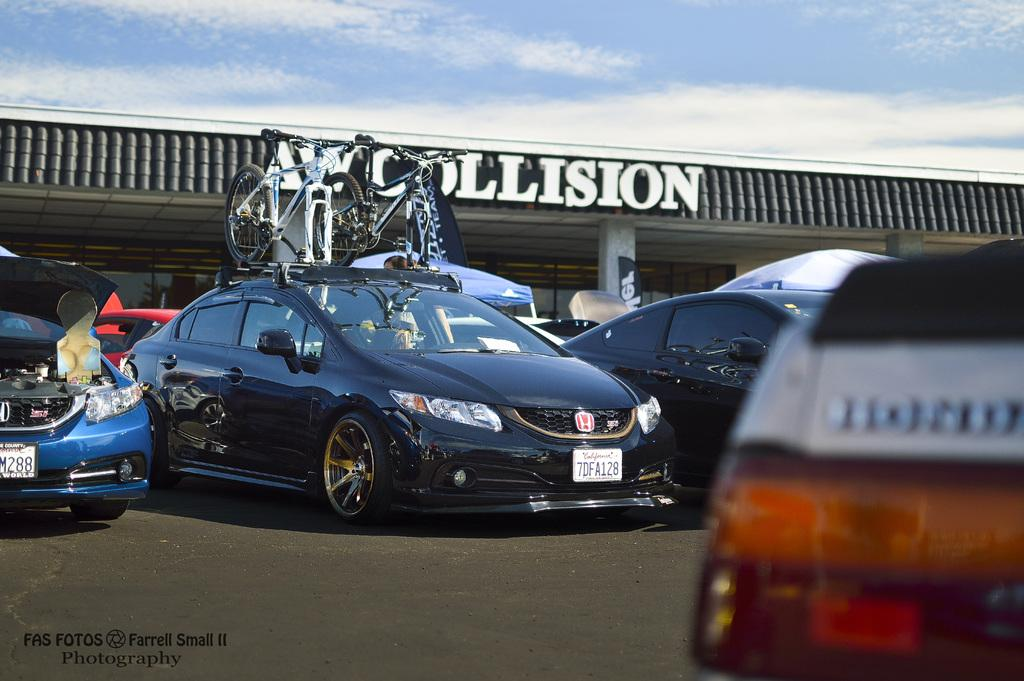Provide a one-sentence caption for the provided image. Cars are parked in a lot in front of the AW Collision building. 